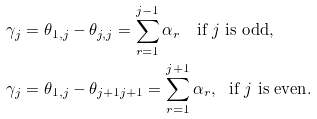<formula> <loc_0><loc_0><loc_500><loc_500>& \gamma _ { j } = \theta _ { 1 , j } - \theta _ { j , j } = \sum _ { r = 1 } ^ { j - 1 } \alpha _ { r } \quad { \text {if $j$ is odd} } , \\ & \gamma _ { j } = \theta _ { 1 , j } - \theta _ { j + 1 j + 1 } = \sum _ { r = 1 } ^ { j + 1 } \alpha _ { r } , \ \ { \text {if $j$ is even} } .</formula> 